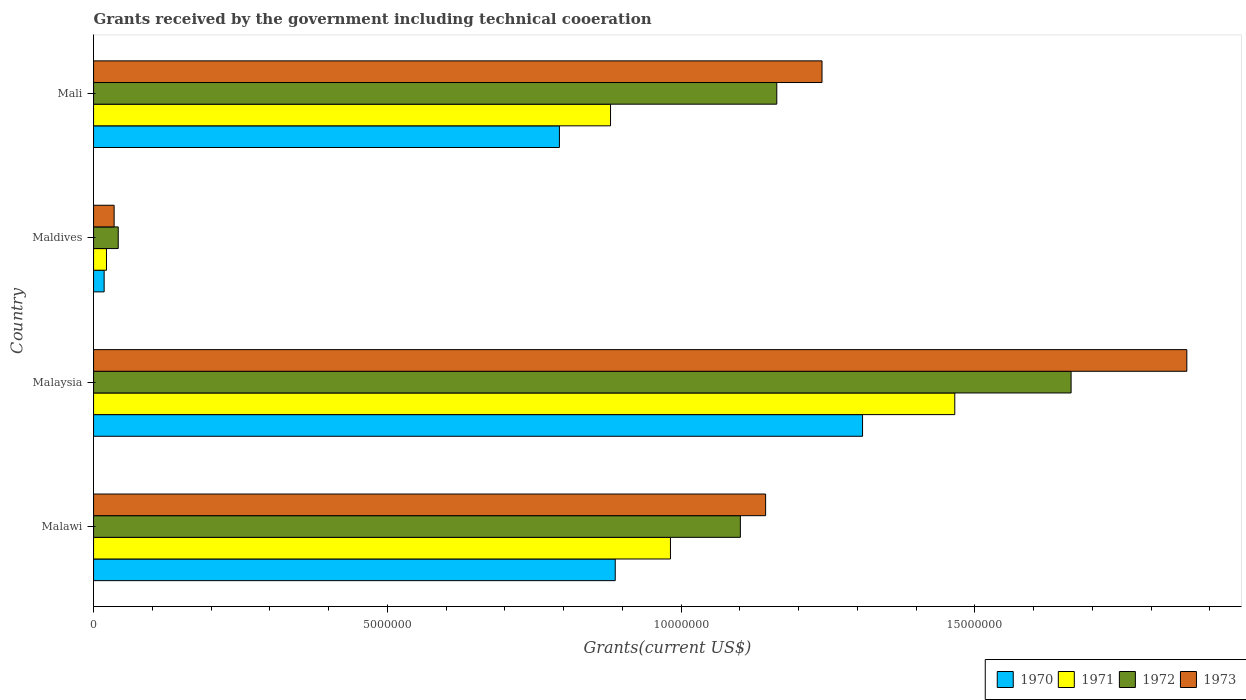How many groups of bars are there?
Your answer should be very brief. 4. Are the number of bars on each tick of the Y-axis equal?
Ensure brevity in your answer.  Yes. How many bars are there on the 4th tick from the bottom?
Ensure brevity in your answer.  4. What is the label of the 3rd group of bars from the top?
Keep it short and to the point. Malaysia. What is the total grants received by the government in 1973 in Malaysia?
Your answer should be very brief. 1.86e+07. Across all countries, what is the maximum total grants received by the government in 1970?
Give a very brief answer. 1.31e+07. In which country was the total grants received by the government in 1973 maximum?
Provide a succinct answer. Malaysia. In which country was the total grants received by the government in 1971 minimum?
Give a very brief answer. Maldives. What is the total total grants received by the government in 1970 in the graph?
Your answer should be compact. 3.01e+07. What is the difference between the total grants received by the government in 1971 in Malaysia and that in Mali?
Give a very brief answer. 5.86e+06. What is the difference between the total grants received by the government in 1970 in Maldives and the total grants received by the government in 1973 in Mali?
Offer a very short reply. -1.22e+07. What is the average total grants received by the government in 1972 per country?
Offer a very short reply. 9.92e+06. What is the ratio of the total grants received by the government in 1972 in Malaysia to that in Maldives?
Give a very brief answer. 39.62. Is the difference between the total grants received by the government in 1973 in Maldives and Mali greater than the difference between the total grants received by the government in 1970 in Maldives and Mali?
Keep it short and to the point. No. What is the difference between the highest and the second highest total grants received by the government in 1970?
Ensure brevity in your answer.  4.21e+06. What is the difference between the highest and the lowest total grants received by the government in 1970?
Your response must be concise. 1.29e+07. In how many countries, is the total grants received by the government in 1972 greater than the average total grants received by the government in 1972 taken over all countries?
Your answer should be compact. 3. Is the sum of the total grants received by the government in 1972 in Malawi and Maldives greater than the maximum total grants received by the government in 1970 across all countries?
Your answer should be very brief. No. How many bars are there?
Keep it short and to the point. 16. What is the difference between two consecutive major ticks on the X-axis?
Offer a terse response. 5.00e+06. Does the graph contain grids?
Your answer should be very brief. No. Where does the legend appear in the graph?
Keep it short and to the point. Bottom right. What is the title of the graph?
Offer a very short reply. Grants received by the government including technical cooeration. Does "1984" appear as one of the legend labels in the graph?
Ensure brevity in your answer.  No. What is the label or title of the X-axis?
Your answer should be compact. Grants(current US$). What is the Grants(current US$) in 1970 in Malawi?
Give a very brief answer. 8.88e+06. What is the Grants(current US$) of 1971 in Malawi?
Offer a very short reply. 9.82e+06. What is the Grants(current US$) of 1972 in Malawi?
Offer a terse response. 1.10e+07. What is the Grants(current US$) of 1973 in Malawi?
Provide a short and direct response. 1.14e+07. What is the Grants(current US$) in 1970 in Malaysia?
Your answer should be very brief. 1.31e+07. What is the Grants(current US$) of 1971 in Malaysia?
Provide a short and direct response. 1.47e+07. What is the Grants(current US$) of 1972 in Malaysia?
Offer a terse response. 1.66e+07. What is the Grants(current US$) of 1973 in Malaysia?
Provide a short and direct response. 1.86e+07. What is the Grants(current US$) of 1971 in Maldives?
Make the answer very short. 2.20e+05. What is the Grants(current US$) in 1970 in Mali?
Provide a succinct answer. 7.93e+06. What is the Grants(current US$) of 1971 in Mali?
Provide a succinct answer. 8.80e+06. What is the Grants(current US$) in 1972 in Mali?
Keep it short and to the point. 1.16e+07. What is the Grants(current US$) in 1973 in Mali?
Offer a terse response. 1.24e+07. Across all countries, what is the maximum Grants(current US$) in 1970?
Your response must be concise. 1.31e+07. Across all countries, what is the maximum Grants(current US$) in 1971?
Offer a terse response. 1.47e+07. Across all countries, what is the maximum Grants(current US$) in 1972?
Ensure brevity in your answer.  1.66e+07. Across all countries, what is the maximum Grants(current US$) of 1973?
Offer a very short reply. 1.86e+07. Across all countries, what is the minimum Grants(current US$) of 1970?
Offer a terse response. 1.80e+05. Across all countries, what is the minimum Grants(current US$) of 1971?
Your answer should be very brief. 2.20e+05. Across all countries, what is the minimum Grants(current US$) in 1972?
Provide a short and direct response. 4.20e+05. What is the total Grants(current US$) in 1970 in the graph?
Offer a very short reply. 3.01e+07. What is the total Grants(current US$) of 1971 in the graph?
Give a very brief answer. 3.35e+07. What is the total Grants(current US$) in 1972 in the graph?
Provide a short and direct response. 3.97e+07. What is the total Grants(current US$) in 1973 in the graph?
Your answer should be very brief. 4.28e+07. What is the difference between the Grants(current US$) of 1970 in Malawi and that in Malaysia?
Offer a very short reply. -4.21e+06. What is the difference between the Grants(current US$) in 1971 in Malawi and that in Malaysia?
Your answer should be compact. -4.84e+06. What is the difference between the Grants(current US$) of 1972 in Malawi and that in Malaysia?
Make the answer very short. -5.63e+06. What is the difference between the Grants(current US$) in 1973 in Malawi and that in Malaysia?
Offer a very short reply. -7.17e+06. What is the difference between the Grants(current US$) of 1970 in Malawi and that in Maldives?
Ensure brevity in your answer.  8.70e+06. What is the difference between the Grants(current US$) of 1971 in Malawi and that in Maldives?
Give a very brief answer. 9.60e+06. What is the difference between the Grants(current US$) of 1972 in Malawi and that in Maldives?
Your response must be concise. 1.06e+07. What is the difference between the Grants(current US$) of 1973 in Malawi and that in Maldives?
Make the answer very short. 1.11e+07. What is the difference between the Grants(current US$) in 1970 in Malawi and that in Mali?
Ensure brevity in your answer.  9.50e+05. What is the difference between the Grants(current US$) of 1971 in Malawi and that in Mali?
Ensure brevity in your answer.  1.02e+06. What is the difference between the Grants(current US$) of 1972 in Malawi and that in Mali?
Your answer should be compact. -6.20e+05. What is the difference between the Grants(current US$) in 1973 in Malawi and that in Mali?
Your response must be concise. -9.60e+05. What is the difference between the Grants(current US$) in 1970 in Malaysia and that in Maldives?
Make the answer very short. 1.29e+07. What is the difference between the Grants(current US$) in 1971 in Malaysia and that in Maldives?
Your answer should be very brief. 1.44e+07. What is the difference between the Grants(current US$) in 1972 in Malaysia and that in Maldives?
Keep it short and to the point. 1.62e+07. What is the difference between the Grants(current US$) in 1973 in Malaysia and that in Maldives?
Provide a succinct answer. 1.83e+07. What is the difference between the Grants(current US$) of 1970 in Malaysia and that in Mali?
Your answer should be very brief. 5.16e+06. What is the difference between the Grants(current US$) of 1971 in Malaysia and that in Mali?
Give a very brief answer. 5.86e+06. What is the difference between the Grants(current US$) in 1972 in Malaysia and that in Mali?
Your response must be concise. 5.01e+06. What is the difference between the Grants(current US$) in 1973 in Malaysia and that in Mali?
Your response must be concise. 6.21e+06. What is the difference between the Grants(current US$) in 1970 in Maldives and that in Mali?
Keep it short and to the point. -7.75e+06. What is the difference between the Grants(current US$) of 1971 in Maldives and that in Mali?
Give a very brief answer. -8.58e+06. What is the difference between the Grants(current US$) of 1972 in Maldives and that in Mali?
Offer a terse response. -1.12e+07. What is the difference between the Grants(current US$) in 1973 in Maldives and that in Mali?
Provide a succinct answer. -1.20e+07. What is the difference between the Grants(current US$) of 1970 in Malawi and the Grants(current US$) of 1971 in Malaysia?
Give a very brief answer. -5.78e+06. What is the difference between the Grants(current US$) of 1970 in Malawi and the Grants(current US$) of 1972 in Malaysia?
Keep it short and to the point. -7.76e+06. What is the difference between the Grants(current US$) of 1970 in Malawi and the Grants(current US$) of 1973 in Malaysia?
Make the answer very short. -9.73e+06. What is the difference between the Grants(current US$) of 1971 in Malawi and the Grants(current US$) of 1972 in Malaysia?
Ensure brevity in your answer.  -6.82e+06. What is the difference between the Grants(current US$) of 1971 in Malawi and the Grants(current US$) of 1973 in Malaysia?
Give a very brief answer. -8.79e+06. What is the difference between the Grants(current US$) of 1972 in Malawi and the Grants(current US$) of 1973 in Malaysia?
Offer a very short reply. -7.60e+06. What is the difference between the Grants(current US$) in 1970 in Malawi and the Grants(current US$) in 1971 in Maldives?
Your answer should be compact. 8.66e+06. What is the difference between the Grants(current US$) of 1970 in Malawi and the Grants(current US$) of 1972 in Maldives?
Your response must be concise. 8.46e+06. What is the difference between the Grants(current US$) of 1970 in Malawi and the Grants(current US$) of 1973 in Maldives?
Provide a short and direct response. 8.53e+06. What is the difference between the Grants(current US$) of 1971 in Malawi and the Grants(current US$) of 1972 in Maldives?
Make the answer very short. 9.40e+06. What is the difference between the Grants(current US$) of 1971 in Malawi and the Grants(current US$) of 1973 in Maldives?
Make the answer very short. 9.47e+06. What is the difference between the Grants(current US$) of 1972 in Malawi and the Grants(current US$) of 1973 in Maldives?
Your response must be concise. 1.07e+07. What is the difference between the Grants(current US$) of 1970 in Malawi and the Grants(current US$) of 1971 in Mali?
Ensure brevity in your answer.  8.00e+04. What is the difference between the Grants(current US$) in 1970 in Malawi and the Grants(current US$) in 1972 in Mali?
Your answer should be compact. -2.75e+06. What is the difference between the Grants(current US$) in 1970 in Malawi and the Grants(current US$) in 1973 in Mali?
Offer a very short reply. -3.52e+06. What is the difference between the Grants(current US$) of 1971 in Malawi and the Grants(current US$) of 1972 in Mali?
Give a very brief answer. -1.81e+06. What is the difference between the Grants(current US$) of 1971 in Malawi and the Grants(current US$) of 1973 in Mali?
Give a very brief answer. -2.58e+06. What is the difference between the Grants(current US$) of 1972 in Malawi and the Grants(current US$) of 1973 in Mali?
Offer a terse response. -1.39e+06. What is the difference between the Grants(current US$) of 1970 in Malaysia and the Grants(current US$) of 1971 in Maldives?
Your answer should be compact. 1.29e+07. What is the difference between the Grants(current US$) of 1970 in Malaysia and the Grants(current US$) of 1972 in Maldives?
Your response must be concise. 1.27e+07. What is the difference between the Grants(current US$) of 1970 in Malaysia and the Grants(current US$) of 1973 in Maldives?
Make the answer very short. 1.27e+07. What is the difference between the Grants(current US$) in 1971 in Malaysia and the Grants(current US$) in 1972 in Maldives?
Ensure brevity in your answer.  1.42e+07. What is the difference between the Grants(current US$) in 1971 in Malaysia and the Grants(current US$) in 1973 in Maldives?
Your answer should be very brief. 1.43e+07. What is the difference between the Grants(current US$) in 1972 in Malaysia and the Grants(current US$) in 1973 in Maldives?
Give a very brief answer. 1.63e+07. What is the difference between the Grants(current US$) in 1970 in Malaysia and the Grants(current US$) in 1971 in Mali?
Ensure brevity in your answer.  4.29e+06. What is the difference between the Grants(current US$) in 1970 in Malaysia and the Grants(current US$) in 1972 in Mali?
Provide a short and direct response. 1.46e+06. What is the difference between the Grants(current US$) in 1970 in Malaysia and the Grants(current US$) in 1973 in Mali?
Offer a very short reply. 6.90e+05. What is the difference between the Grants(current US$) of 1971 in Malaysia and the Grants(current US$) of 1972 in Mali?
Your response must be concise. 3.03e+06. What is the difference between the Grants(current US$) in 1971 in Malaysia and the Grants(current US$) in 1973 in Mali?
Your answer should be very brief. 2.26e+06. What is the difference between the Grants(current US$) of 1972 in Malaysia and the Grants(current US$) of 1973 in Mali?
Keep it short and to the point. 4.24e+06. What is the difference between the Grants(current US$) of 1970 in Maldives and the Grants(current US$) of 1971 in Mali?
Make the answer very short. -8.62e+06. What is the difference between the Grants(current US$) of 1970 in Maldives and the Grants(current US$) of 1972 in Mali?
Offer a very short reply. -1.14e+07. What is the difference between the Grants(current US$) of 1970 in Maldives and the Grants(current US$) of 1973 in Mali?
Keep it short and to the point. -1.22e+07. What is the difference between the Grants(current US$) in 1971 in Maldives and the Grants(current US$) in 1972 in Mali?
Provide a succinct answer. -1.14e+07. What is the difference between the Grants(current US$) of 1971 in Maldives and the Grants(current US$) of 1973 in Mali?
Provide a succinct answer. -1.22e+07. What is the difference between the Grants(current US$) of 1972 in Maldives and the Grants(current US$) of 1973 in Mali?
Keep it short and to the point. -1.20e+07. What is the average Grants(current US$) of 1970 per country?
Your answer should be compact. 7.52e+06. What is the average Grants(current US$) in 1971 per country?
Provide a succinct answer. 8.38e+06. What is the average Grants(current US$) of 1972 per country?
Make the answer very short. 9.92e+06. What is the average Grants(current US$) of 1973 per country?
Ensure brevity in your answer.  1.07e+07. What is the difference between the Grants(current US$) of 1970 and Grants(current US$) of 1971 in Malawi?
Your answer should be compact. -9.40e+05. What is the difference between the Grants(current US$) in 1970 and Grants(current US$) in 1972 in Malawi?
Offer a very short reply. -2.13e+06. What is the difference between the Grants(current US$) in 1970 and Grants(current US$) in 1973 in Malawi?
Offer a terse response. -2.56e+06. What is the difference between the Grants(current US$) of 1971 and Grants(current US$) of 1972 in Malawi?
Keep it short and to the point. -1.19e+06. What is the difference between the Grants(current US$) in 1971 and Grants(current US$) in 1973 in Malawi?
Your answer should be very brief. -1.62e+06. What is the difference between the Grants(current US$) in 1972 and Grants(current US$) in 1973 in Malawi?
Your answer should be very brief. -4.30e+05. What is the difference between the Grants(current US$) in 1970 and Grants(current US$) in 1971 in Malaysia?
Ensure brevity in your answer.  -1.57e+06. What is the difference between the Grants(current US$) in 1970 and Grants(current US$) in 1972 in Malaysia?
Your answer should be compact. -3.55e+06. What is the difference between the Grants(current US$) of 1970 and Grants(current US$) of 1973 in Malaysia?
Offer a terse response. -5.52e+06. What is the difference between the Grants(current US$) of 1971 and Grants(current US$) of 1972 in Malaysia?
Provide a short and direct response. -1.98e+06. What is the difference between the Grants(current US$) in 1971 and Grants(current US$) in 1973 in Malaysia?
Offer a terse response. -3.95e+06. What is the difference between the Grants(current US$) in 1972 and Grants(current US$) in 1973 in Malaysia?
Give a very brief answer. -1.97e+06. What is the difference between the Grants(current US$) in 1970 and Grants(current US$) in 1971 in Maldives?
Your response must be concise. -4.00e+04. What is the difference between the Grants(current US$) of 1970 and Grants(current US$) of 1972 in Maldives?
Provide a short and direct response. -2.40e+05. What is the difference between the Grants(current US$) in 1970 and Grants(current US$) in 1973 in Maldives?
Ensure brevity in your answer.  -1.70e+05. What is the difference between the Grants(current US$) of 1971 and Grants(current US$) of 1972 in Maldives?
Provide a succinct answer. -2.00e+05. What is the difference between the Grants(current US$) of 1971 and Grants(current US$) of 1973 in Maldives?
Offer a terse response. -1.30e+05. What is the difference between the Grants(current US$) in 1970 and Grants(current US$) in 1971 in Mali?
Provide a succinct answer. -8.70e+05. What is the difference between the Grants(current US$) of 1970 and Grants(current US$) of 1972 in Mali?
Provide a short and direct response. -3.70e+06. What is the difference between the Grants(current US$) in 1970 and Grants(current US$) in 1973 in Mali?
Give a very brief answer. -4.47e+06. What is the difference between the Grants(current US$) in 1971 and Grants(current US$) in 1972 in Mali?
Give a very brief answer. -2.83e+06. What is the difference between the Grants(current US$) in 1971 and Grants(current US$) in 1973 in Mali?
Offer a very short reply. -3.60e+06. What is the difference between the Grants(current US$) in 1972 and Grants(current US$) in 1973 in Mali?
Ensure brevity in your answer.  -7.70e+05. What is the ratio of the Grants(current US$) of 1970 in Malawi to that in Malaysia?
Your response must be concise. 0.68. What is the ratio of the Grants(current US$) in 1971 in Malawi to that in Malaysia?
Offer a terse response. 0.67. What is the ratio of the Grants(current US$) in 1972 in Malawi to that in Malaysia?
Your answer should be compact. 0.66. What is the ratio of the Grants(current US$) of 1973 in Malawi to that in Malaysia?
Your answer should be very brief. 0.61. What is the ratio of the Grants(current US$) of 1970 in Malawi to that in Maldives?
Provide a succinct answer. 49.33. What is the ratio of the Grants(current US$) in 1971 in Malawi to that in Maldives?
Provide a short and direct response. 44.64. What is the ratio of the Grants(current US$) in 1972 in Malawi to that in Maldives?
Provide a short and direct response. 26.21. What is the ratio of the Grants(current US$) of 1973 in Malawi to that in Maldives?
Your response must be concise. 32.69. What is the ratio of the Grants(current US$) of 1970 in Malawi to that in Mali?
Provide a short and direct response. 1.12. What is the ratio of the Grants(current US$) in 1971 in Malawi to that in Mali?
Ensure brevity in your answer.  1.12. What is the ratio of the Grants(current US$) in 1972 in Malawi to that in Mali?
Your response must be concise. 0.95. What is the ratio of the Grants(current US$) in 1973 in Malawi to that in Mali?
Make the answer very short. 0.92. What is the ratio of the Grants(current US$) in 1970 in Malaysia to that in Maldives?
Ensure brevity in your answer.  72.72. What is the ratio of the Grants(current US$) of 1971 in Malaysia to that in Maldives?
Make the answer very short. 66.64. What is the ratio of the Grants(current US$) in 1972 in Malaysia to that in Maldives?
Ensure brevity in your answer.  39.62. What is the ratio of the Grants(current US$) in 1973 in Malaysia to that in Maldives?
Offer a very short reply. 53.17. What is the ratio of the Grants(current US$) of 1970 in Malaysia to that in Mali?
Make the answer very short. 1.65. What is the ratio of the Grants(current US$) of 1971 in Malaysia to that in Mali?
Ensure brevity in your answer.  1.67. What is the ratio of the Grants(current US$) of 1972 in Malaysia to that in Mali?
Give a very brief answer. 1.43. What is the ratio of the Grants(current US$) of 1973 in Malaysia to that in Mali?
Your answer should be very brief. 1.5. What is the ratio of the Grants(current US$) of 1970 in Maldives to that in Mali?
Your answer should be very brief. 0.02. What is the ratio of the Grants(current US$) in 1971 in Maldives to that in Mali?
Ensure brevity in your answer.  0.03. What is the ratio of the Grants(current US$) in 1972 in Maldives to that in Mali?
Offer a very short reply. 0.04. What is the ratio of the Grants(current US$) in 1973 in Maldives to that in Mali?
Give a very brief answer. 0.03. What is the difference between the highest and the second highest Grants(current US$) in 1970?
Your answer should be very brief. 4.21e+06. What is the difference between the highest and the second highest Grants(current US$) in 1971?
Make the answer very short. 4.84e+06. What is the difference between the highest and the second highest Grants(current US$) of 1972?
Keep it short and to the point. 5.01e+06. What is the difference between the highest and the second highest Grants(current US$) in 1973?
Your response must be concise. 6.21e+06. What is the difference between the highest and the lowest Grants(current US$) in 1970?
Your answer should be compact. 1.29e+07. What is the difference between the highest and the lowest Grants(current US$) in 1971?
Offer a terse response. 1.44e+07. What is the difference between the highest and the lowest Grants(current US$) in 1972?
Offer a very short reply. 1.62e+07. What is the difference between the highest and the lowest Grants(current US$) of 1973?
Provide a succinct answer. 1.83e+07. 